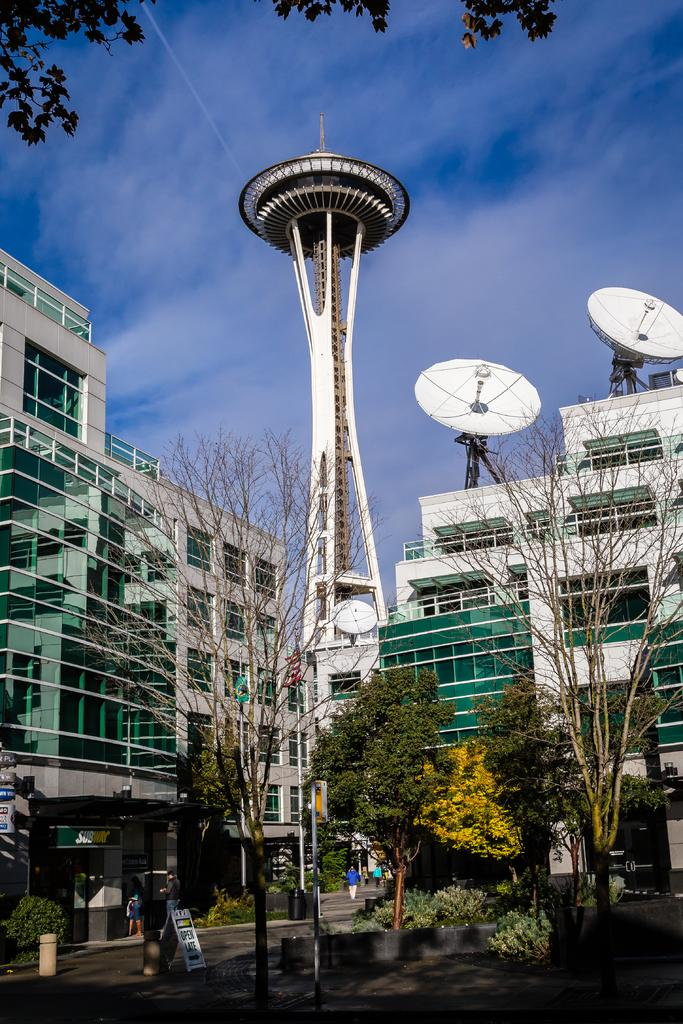What type of natural elements can be seen in the image? There are trees in the image. What type of man-made structures are present in the image? There are buildings in the image. What object in the image is used for displaying information? There is a board in the image. What object in the image is used for waste disposal? There is a bin in the image. What type of communication devices are visible in the image? There are antennas in the image. What objects in the image are used for displaying names or labels? There are name boards in the image. How many people are on the ground in the image? There are two people on the ground in the image. What is visible in the background of the image? The sky is visible in the background of the image. What type of weather condition can be inferred from the image? The presence of clouds in the sky suggests that the weather might be partly cloudy. What type of fang can be seen in the image? There is no fang present in the image. What type of relation can be seen between the two people in the image? The image does not provide enough information to determine the relationship between the two people. 